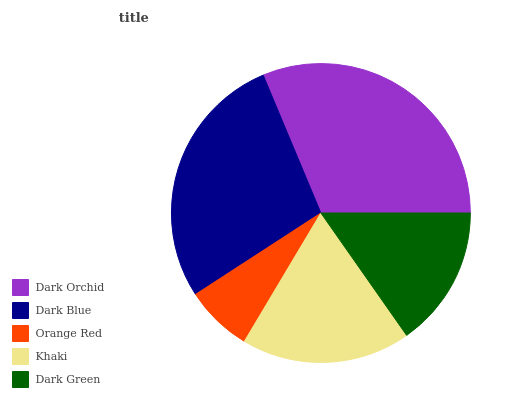Is Orange Red the minimum?
Answer yes or no. Yes. Is Dark Orchid the maximum?
Answer yes or no. Yes. Is Dark Blue the minimum?
Answer yes or no. No. Is Dark Blue the maximum?
Answer yes or no. No. Is Dark Orchid greater than Dark Blue?
Answer yes or no. Yes. Is Dark Blue less than Dark Orchid?
Answer yes or no. Yes. Is Dark Blue greater than Dark Orchid?
Answer yes or no. No. Is Dark Orchid less than Dark Blue?
Answer yes or no. No. Is Khaki the high median?
Answer yes or no. Yes. Is Khaki the low median?
Answer yes or no. Yes. Is Dark Blue the high median?
Answer yes or no. No. Is Dark Green the low median?
Answer yes or no. No. 